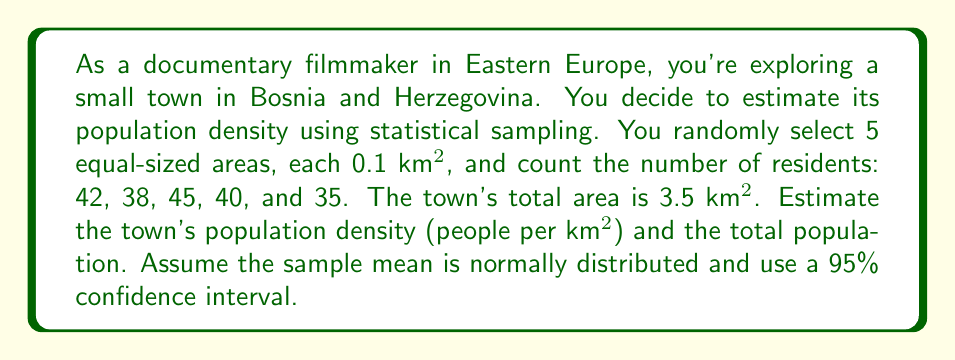Help me with this question. 1. Calculate the sample mean ($\bar{x}$):
   $$\bar{x} = \frac{42 + 38 + 45 + 40 + 35}{5} = 40$$ people per 0.1 km²

2. Calculate the sample standard deviation ($s$):
   $$s = \sqrt{\frac{\sum_{i=1}^{n} (x_i - \bar{x})^2}{n-1}}$$
   $$s = \sqrt{\frac{(42-40)^2 + (38-40)^2 + (45-40)^2 + (40-40)^2 + (35-40)^2}{5-1}} = 3.87$$

3. Calculate the standard error ($SE$):
   $$SE = \frac{s}{\sqrt{n}} = \frac{3.87}{\sqrt{5}} = 1.73$$

4. For a 95% confidence interval, use t-value for 4 degrees of freedom: $t_{0.025,4} = 2.776$

5. Calculate the margin of error ($ME$):
   $$ME = t_{0.025,4} \times SE = 2.776 \times 1.73 = 4.80$$

6. Compute the 95% confidence interval for the mean number of people per 0.1 km²:
   $$40 \pm 4.80 \text{ or } (35.20, 44.80)$$

7. Convert to population density per km²:
   $$352 \pm 48 \text{ people per km²}$$

8. Estimate total population:
   $$\text{Total population} = \text{Density} \times \text{Area} = 400 \times 3.5 = 1400$$

9. Calculate the confidence interval for total population:
   $$1400 \pm (48 \times 3.5) = 1400 \pm 168$$
Answer: Population density: $400 \pm 48$ people/km²; Total population: $1400 \pm 168$ 